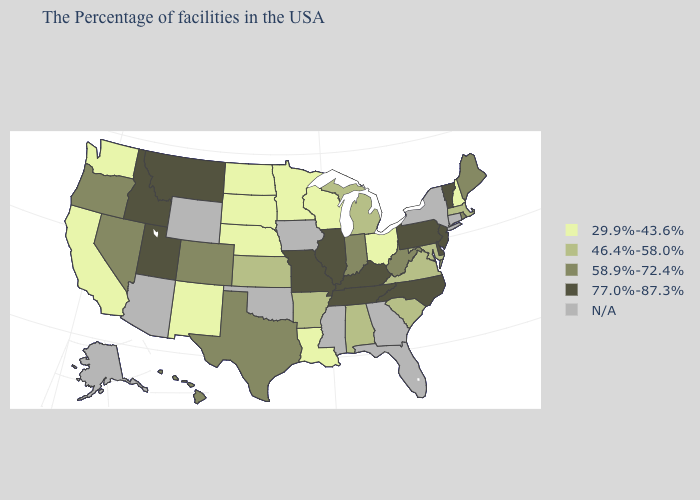Name the states that have a value in the range 58.9%-72.4%?
Quick response, please. Maine, Rhode Island, West Virginia, Indiana, Texas, Colorado, Nevada, Oregon, Hawaii. Name the states that have a value in the range N/A?
Quick response, please. Connecticut, New York, Florida, Georgia, Mississippi, Iowa, Oklahoma, Wyoming, Arizona, Alaska. Name the states that have a value in the range 46.4%-58.0%?
Concise answer only. Massachusetts, Maryland, Virginia, South Carolina, Michigan, Alabama, Arkansas, Kansas. What is the highest value in states that border North Dakota?
Answer briefly. 77.0%-87.3%. What is the value of Montana?
Write a very short answer. 77.0%-87.3%. What is the value of Illinois?
Quick response, please. 77.0%-87.3%. Does Michigan have the highest value in the USA?
Quick response, please. No. Does the first symbol in the legend represent the smallest category?
Be succinct. Yes. Name the states that have a value in the range 77.0%-87.3%?
Keep it brief. Vermont, New Jersey, Delaware, Pennsylvania, North Carolina, Kentucky, Tennessee, Illinois, Missouri, Utah, Montana, Idaho. What is the value of South Dakota?
Concise answer only. 29.9%-43.6%. Name the states that have a value in the range 29.9%-43.6%?
Give a very brief answer. New Hampshire, Ohio, Wisconsin, Louisiana, Minnesota, Nebraska, South Dakota, North Dakota, New Mexico, California, Washington. What is the highest value in states that border Wyoming?
Answer briefly. 77.0%-87.3%. Does Tennessee have the highest value in the South?
Give a very brief answer. Yes. What is the lowest value in states that border Colorado?
Write a very short answer. 29.9%-43.6%. 